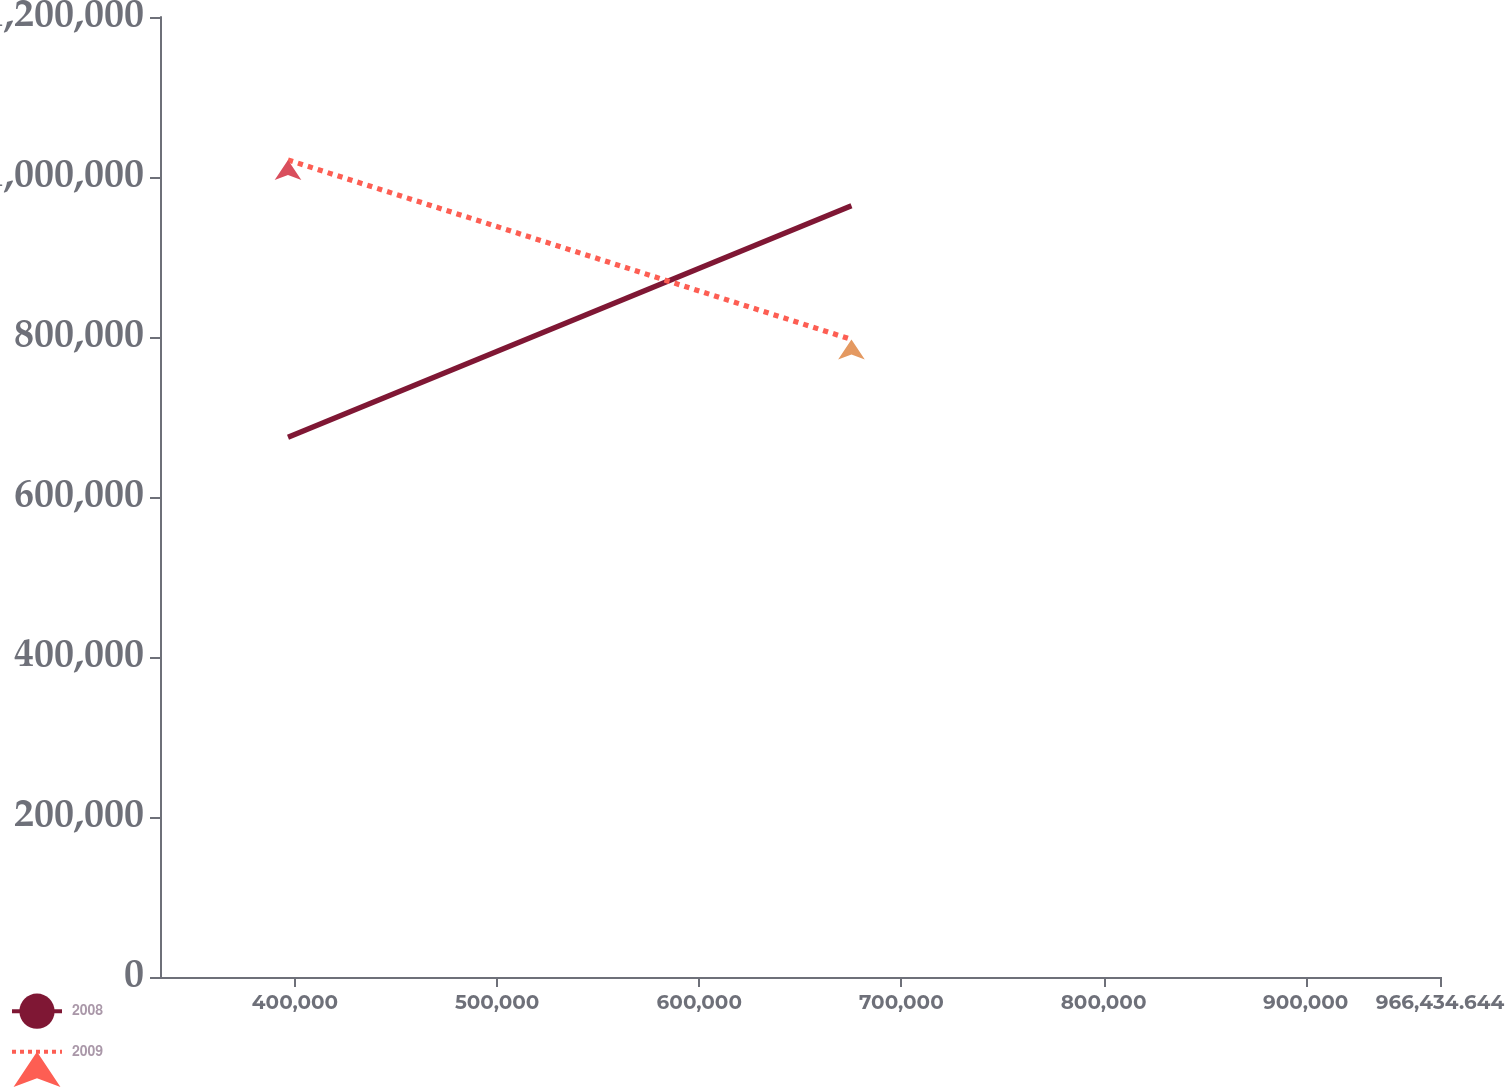Convert chart. <chart><loc_0><loc_0><loc_500><loc_500><line_chart><ecel><fcel>2008<fcel>2009<nl><fcel>396541<fcel>674714<fcel>1.02127e+06<nl><fcel>675285<fcel>964056<fcel>796903<nl><fcel>1.02976e+06<fcel>425589<fcel>298428<nl></chart> 